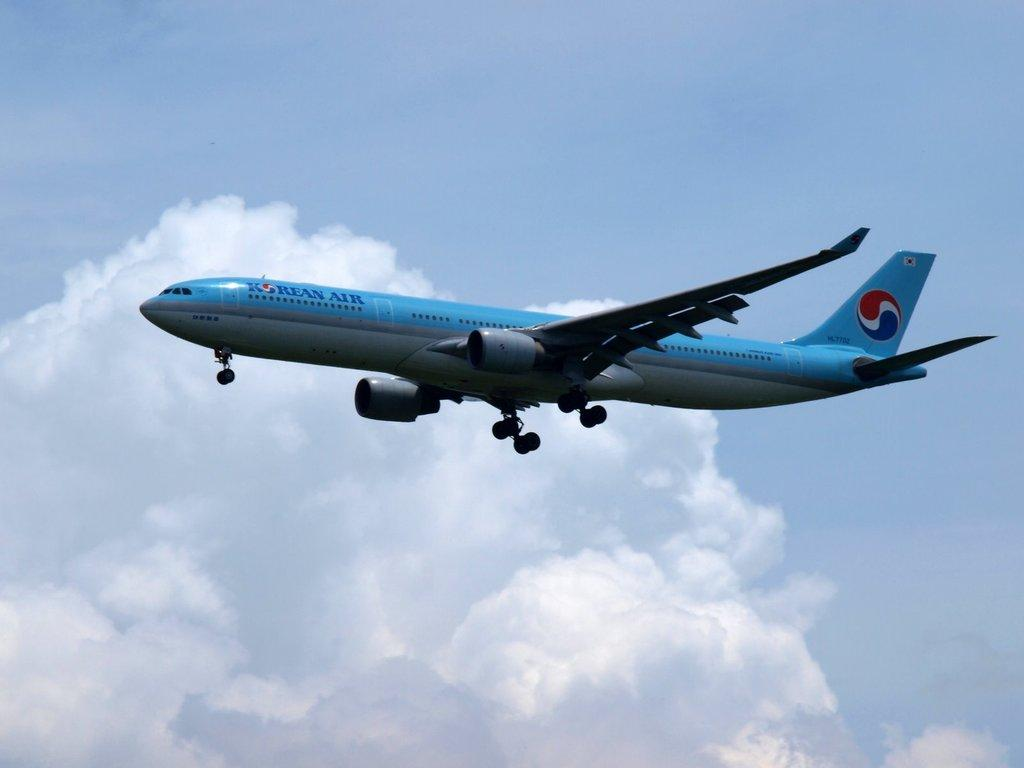<image>
Render a clear and concise summary of the photo. the name Korean Air is on the side of a plane 